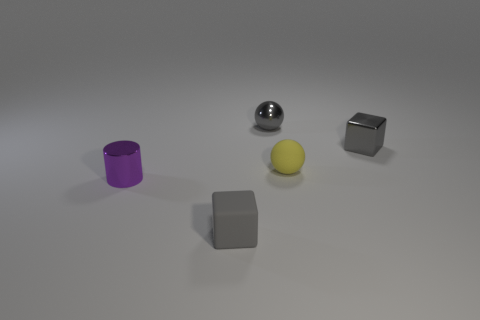The metal object that is the same color as the tiny shiny ball is what shape?
Ensure brevity in your answer.  Cube. What is the size of the rubber thing that is the same color as the metal ball?
Your response must be concise. Small. There is a small thing to the left of the gray rubber object; what shape is it?
Offer a very short reply. Cylinder. Is the number of shiny blocks greater than the number of gray cubes?
Provide a short and direct response. No. Is the color of the tiny cube in front of the tiny yellow matte object the same as the tiny cylinder?
Your answer should be very brief. No. How many things are either shiny things right of the gray shiny sphere or gray metal things that are to the right of the yellow ball?
Give a very brief answer. 1. How many cubes are in front of the purple thing and behind the yellow matte thing?
Your response must be concise. 0. Does the purple object have the same material as the tiny yellow thing?
Ensure brevity in your answer.  No. What shape is the matte object that is behind the small purple cylinder that is in front of the small ball that is on the left side of the tiny yellow rubber ball?
Offer a terse response. Sphere. What is the material of the object that is both in front of the small yellow thing and right of the small purple thing?
Ensure brevity in your answer.  Rubber. 